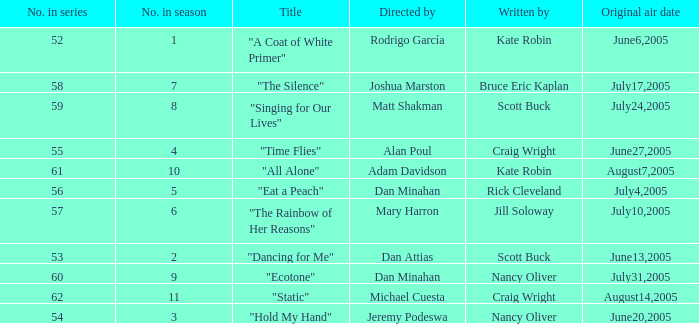What date was episode 10 in the season originally aired? August7,2005. 